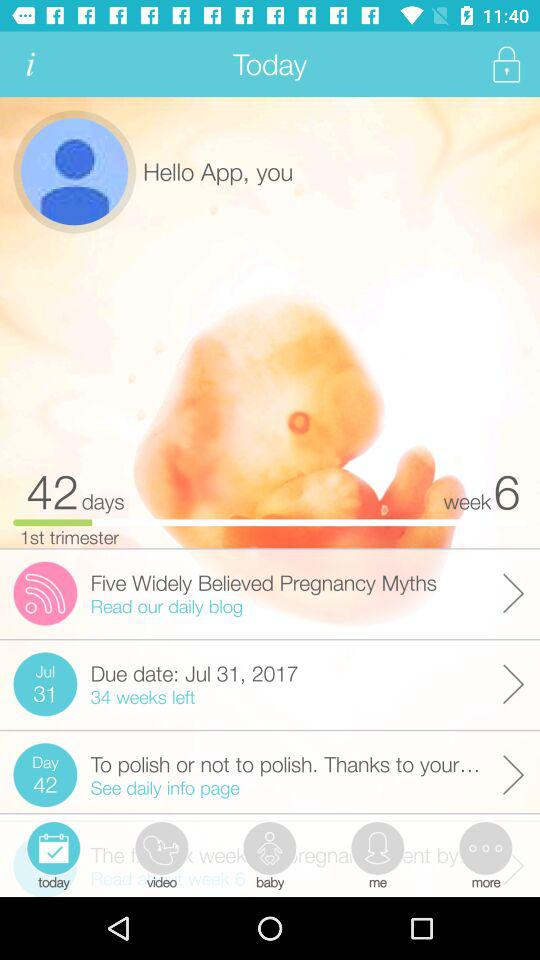What is the mentioned week number? The mentioned week number is 6. 